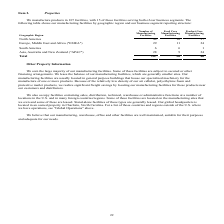According to Sealed Air Corporation's financial document, How many facilities serve both business segments? According to the financial document, 15. The relevant text states: "We manufacture products in 107 facilities, with 15 of those facilities serving both of our business segments. The following table shows our manufactur..." Also, Where are the manufacturing facilities usually located? General purpose buildings. The document states: "r manufacturing facilities are usually located in general purpose buildings that house our specialized machinery for the manufacture of one or more pr..." Also, Where is the Global headquarters located? Charlotte, North Carolina. The document states: "l headquarters is located in an owned property in Charlotte, North Carolina. For a list of those countries and regions outside of the U.S. where we ha..." Also, can you calculate: How many manufacturing facilities in North America are both Food Care and Product Care? Based on the calculation: (10+37)-44, the result is 3. This is based on the information: "Care Manufacturing Facilities North America 44 10 37 ct Care Manufacturing Facilities North America 44 10 37 oduct Care Manufacturing Facilities North America 44 10 37..." The key data points involved are: 10, 37, 44. Also, can you calculate: What is the percentage of manufacturing facilities that are in South America? Based on the calculation: (6/107), the result is 5.61 (percentage). This is based on the information: "Total 107 36 86 Total 107 36 86..." The key data points involved are: 107. Also, can you calculate: How many manufacturing facilities serve only Product Care in total?  Based on the calculation: 107-36, the result is 71. This is based on the information: "Total 107 36 86 Total 107 36 86..." The key data points involved are: 107, 36. 